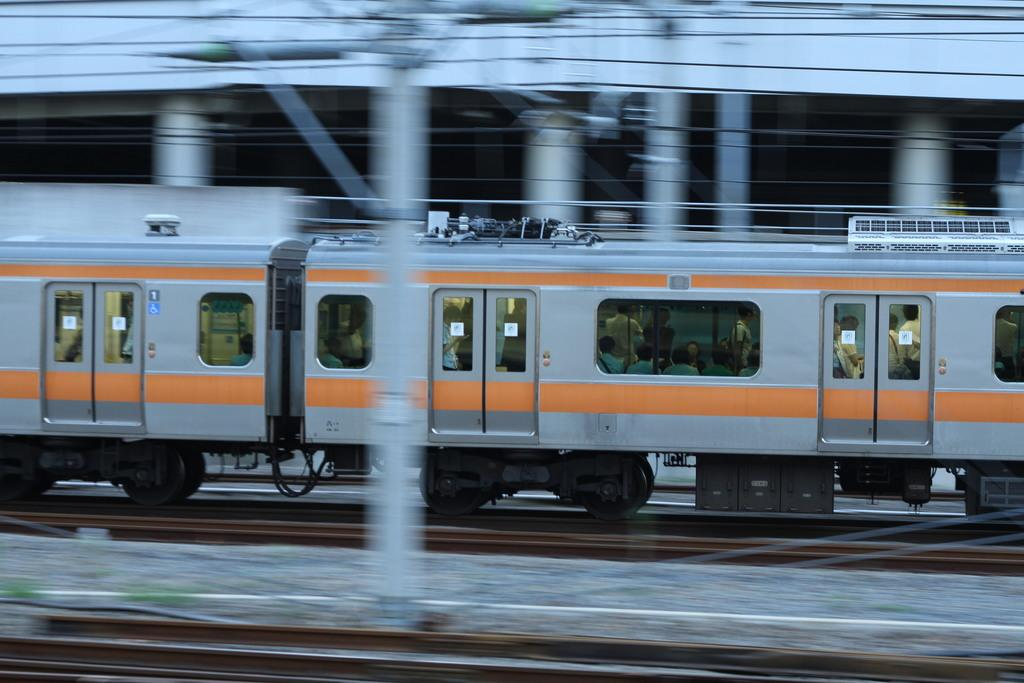What is the main subject of the image? The main subject of the image is a train. What can be observed about the train's position in the image? The train is on a track. What colors are used to depict the train? The train is grey and orange in color. Can you tell if there are any passengers inside the train? Yes, there are people inside the train. What other track is visible in the image? There is another track at the bottom of the image. How many fish can be seen biting the train in the image? There are no fish present in the image, nor are any fish biting the train. 